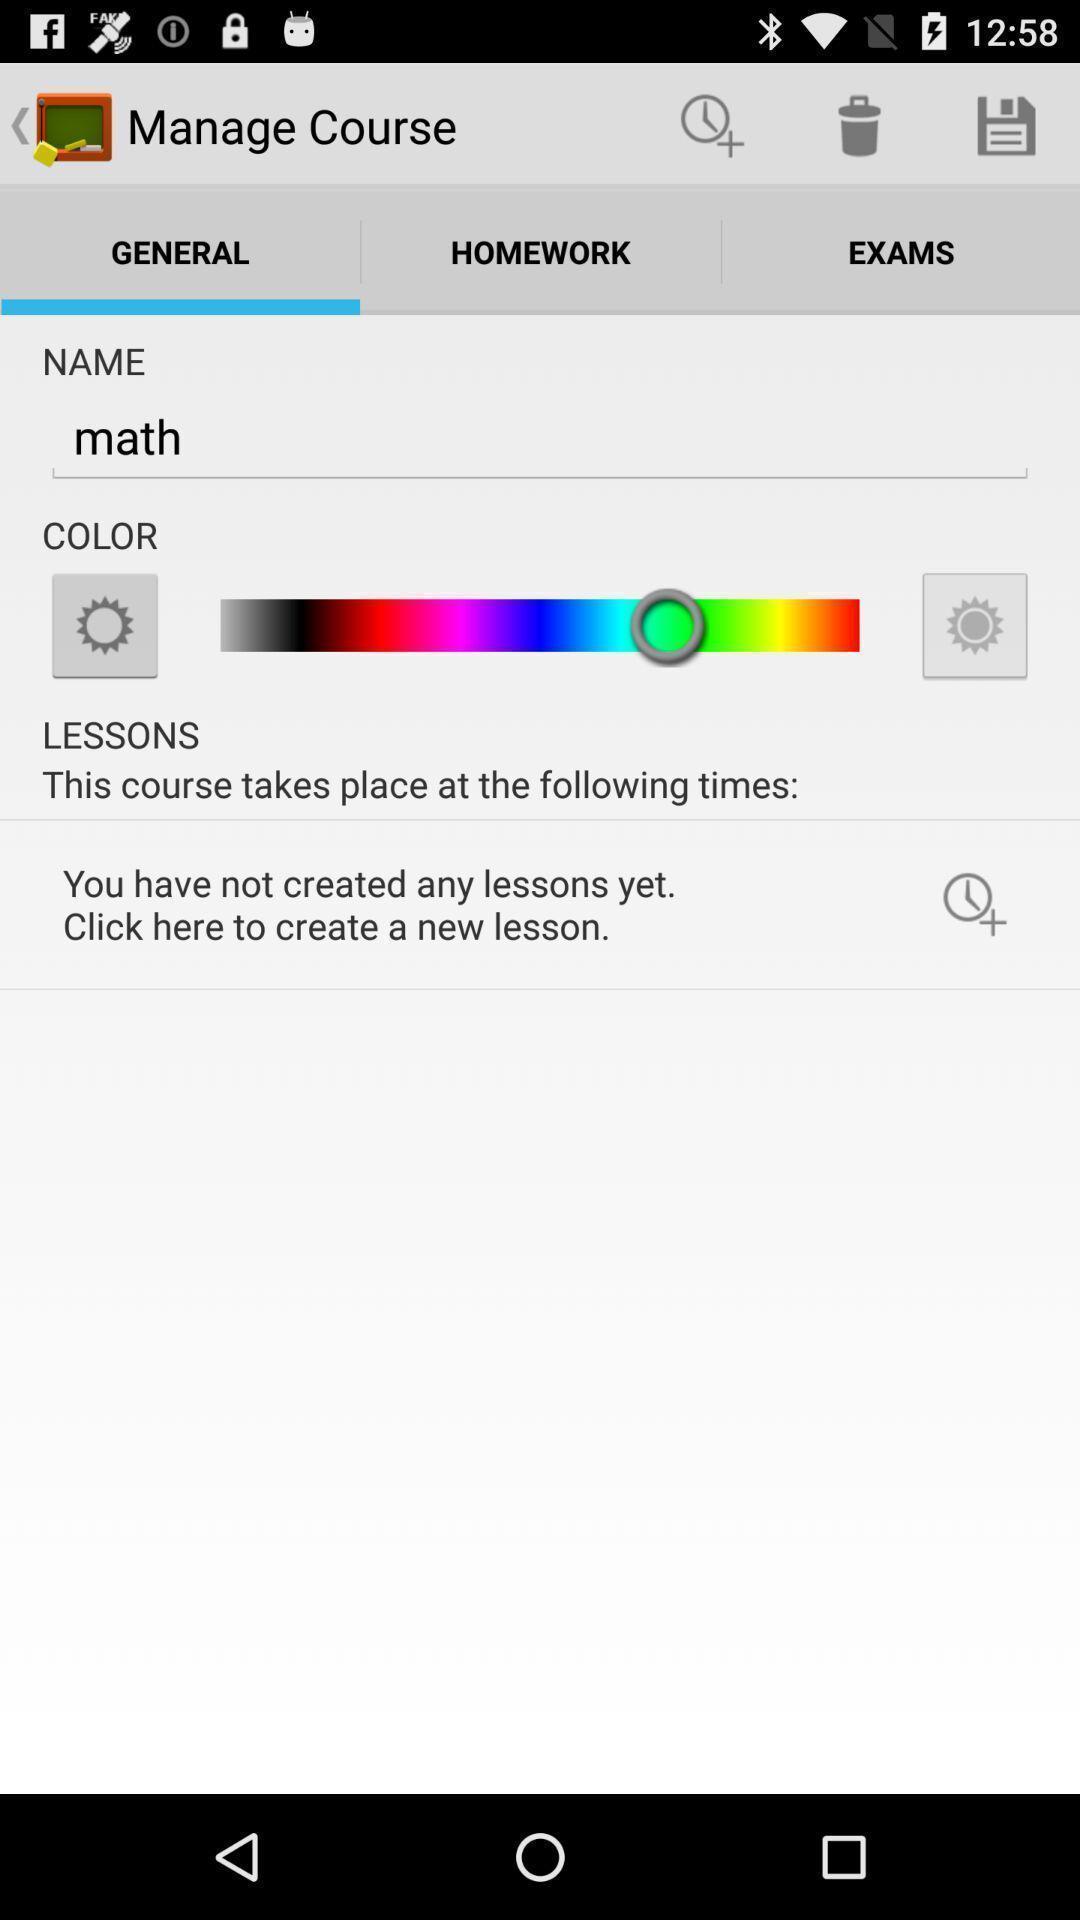Provide a description of this screenshot. Screen displaying the general settings page. 